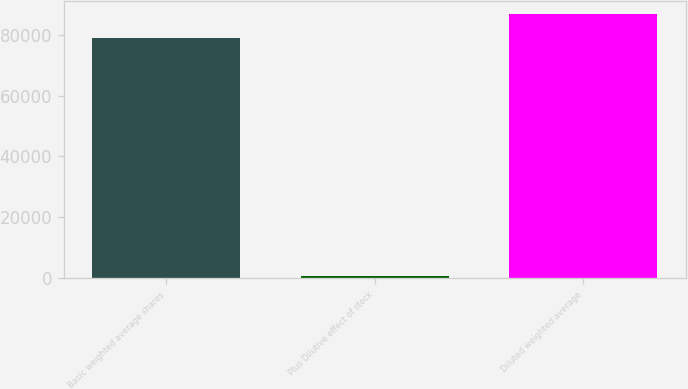<chart> <loc_0><loc_0><loc_500><loc_500><bar_chart><fcel>Basic weighted average shares<fcel>Plus Dilutive effect of stock<fcel>Diluted weighted average<nl><fcel>78829<fcel>602<fcel>86711.9<nl></chart> 